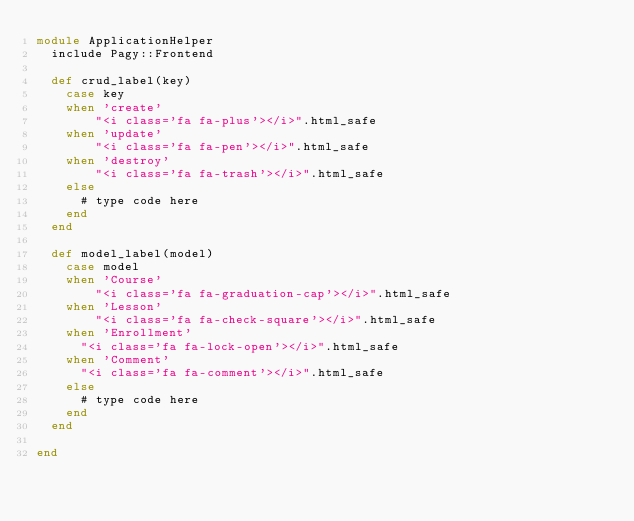<code> <loc_0><loc_0><loc_500><loc_500><_Ruby_>module ApplicationHelper
  include Pagy::Frontend

  def crud_label(key)
    case key
    when 'create'
        "<i class='fa fa-plus'></i>".html_safe
    when 'update'
        "<i class='fa fa-pen'></i>".html_safe
    when 'destroy'
        "<i class='fa fa-trash'></i>".html_safe
    else
      # type code here
    end
  end

  def model_label(model)
    case model
    when 'Course'
        "<i class='fa fa-graduation-cap'></i>".html_safe
    when 'Lesson'
        "<i class='fa fa-check-square'></i>".html_safe
    when 'Enrollment'
      "<i class='fa fa-lock-open'></i>".html_safe
    when 'Comment'
      "<i class='fa fa-comment'></i>".html_safe
    else
      # type code here
    end
  end

end
</code> 